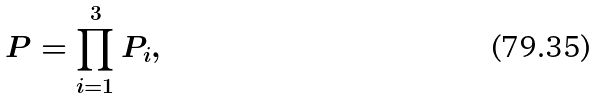<formula> <loc_0><loc_0><loc_500><loc_500>P = \prod _ { i = 1 } ^ { 3 } P _ { i } ,</formula> 